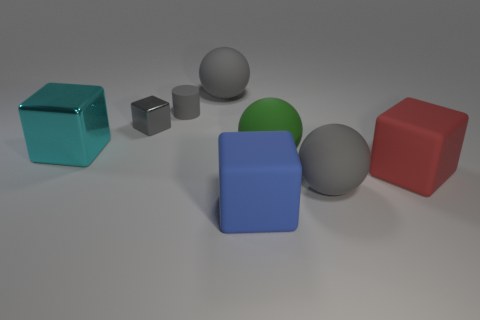What number of small rubber cylinders have the same color as the small metal object?
Your answer should be very brief. 1. What number of things are cubes on the left side of the large red matte cube or tiny red shiny cylinders?
Keep it short and to the point. 3. There is a gray matte sphere that is in front of the cyan metallic thing; how big is it?
Provide a short and direct response. Large. Are there fewer spheres than small cyan cubes?
Provide a short and direct response. No. Do the tiny object that is to the left of the tiny matte cylinder and the cube on the right side of the green object have the same material?
Provide a short and direct response. No. There is a big green rubber object that is to the left of the big gray ball in front of the object that is behind the tiny gray cylinder; what shape is it?
Your answer should be very brief. Sphere. What number of other big cubes have the same material as the blue cube?
Offer a very short reply. 1. What number of small things are on the right side of the gray object on the right side of the big blue cube?
Your answer should be compact. 0. There is a shiny block that is in front of the small shiny object; does it have the same color as the matte cube that is in front of the big red matte object?
Your answer should be compact. No. The rubber object that is both left of the large red thing and right of the large green ball has what shape?
Offer a very short reply. Sphere. 